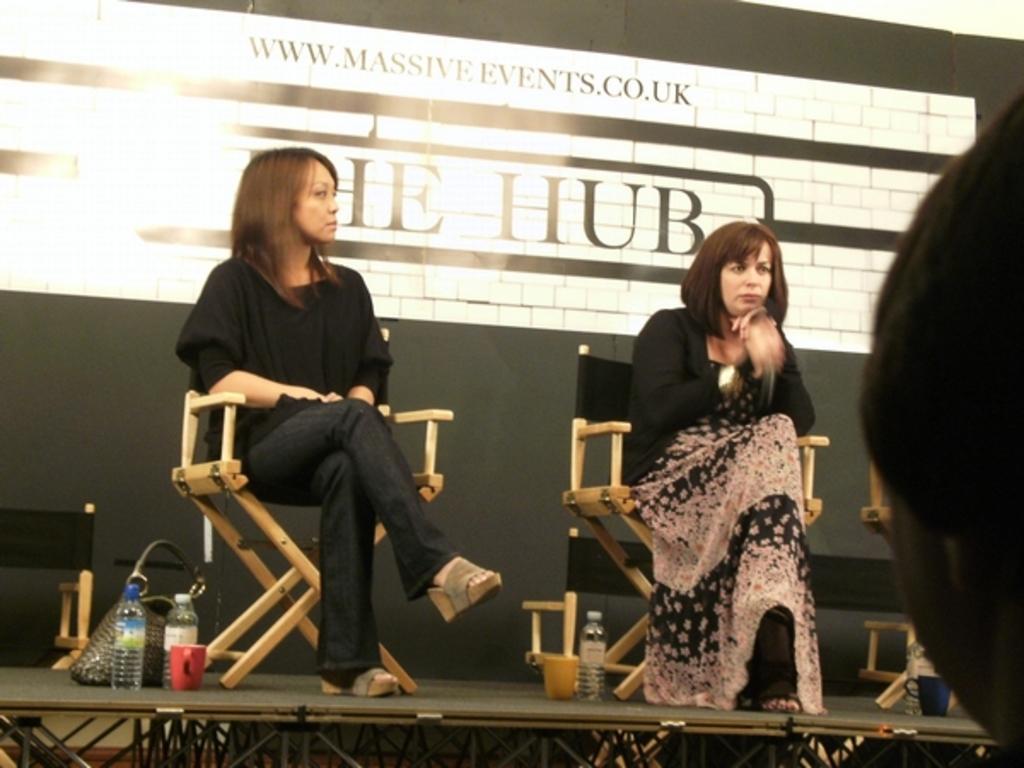Describe this image in one or two sentences. In this image there are two persons sitting on the chair, there is a stage, there are objects on the stage, there is a chair truncated towards the left of the image, there is a person truncated towards the right of the image, there is a blackboard behind the persons, there is text on the board. 